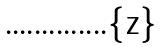Convert formula to latex. <formula><loc_0><loc_0><loc_500><loc_500>\</formula> 